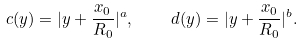<formula> <loc_0><loc_0><loc_500><loc_500>c ( y ) = | y + \frac { x _ { 0 } } { R _ { 0 } } | ^ { a } , \quad d ( y ) = | y + \frac { x _ { 0 } } { R _ { 0 } } | ^ { b } .</formula> 